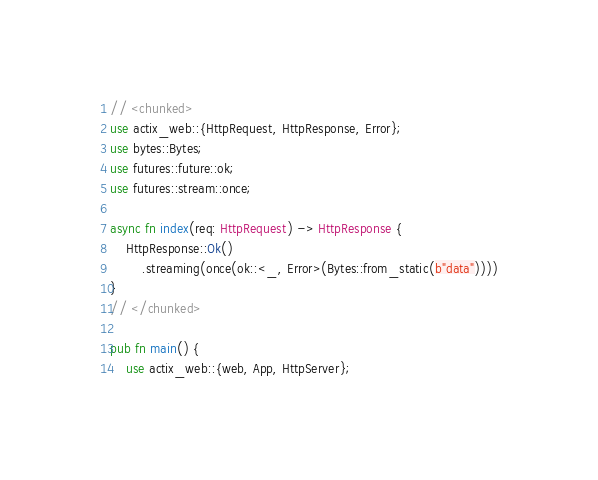Convert code to text. <code><loc_0><loc_0><loc_500><loc_500><_Rust_>// <chunked>
use actix_web::{HttpRequest, HttpResponse, Error};
use bytes::Bytes;
use futures::future::ok;
use futures::stream::once;

async fn index(req: HttpRequest) -> HttpResponse {
    HttpResponse::Ok()
        .streaming(once(ok::<_, Error>(Bytes::from_static(b"data"))))
}
// </chunked>

pub fn main() {
    use actix_web::{web, App, HttpServer};
</code> 